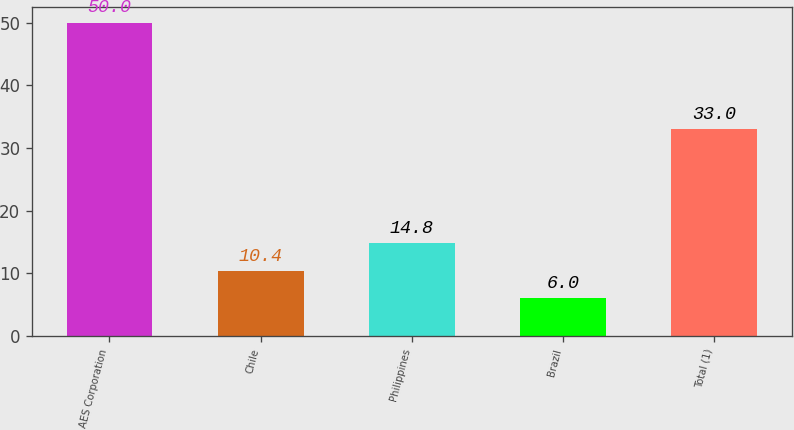Convert chart to OTSL. <chart><loc_0><loc_0><loc_500><loc_500><bar_chart><fcel>AES Corporation<fcel>Chile<fcel>Philippines<fcel>Brazil<fcel>Total (1)<nl><fcel>50<fcel>10.4<fcel>14.8<fcel>6<fcel>33<nl></chart> 